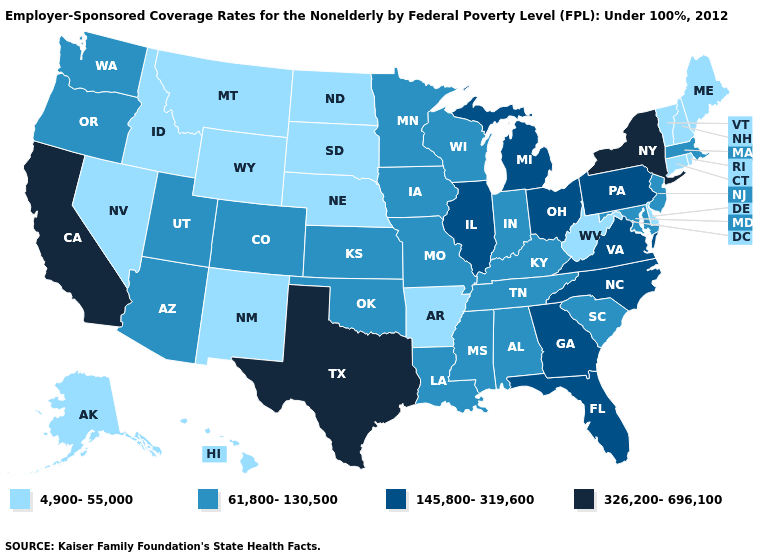What is the value of North Dakota?
Answer briefly. 4,900-55,000. Name the states that have a value in the range 145,800-319,600?
Short answer required. Florida, Georgia, Illinois, Michigan, North Carolina, Ohio, Pennsylvania, Virginia. Name the states that have a value in the range 326,200-696,100?
Write a very short answer. California, New York, Texas. Does the map have missing data?
Short answer required. No. What is the value of Oklahoma?
Quick response, please. 61,800-130,500. Name the states that have a value in the range 326,200-696,100?
Quick response, please. California, New York, Texas. Name the states that have a value in the range 326,200-696,100?
Keep it brief. California, New York, Texas. Name the states that have a value in the range 145,800-319,600?
Concise answer only. Florida, Georgia, Illinois, Michigan, North Carolina, Ohio, Pennsylvania, Virginia. Does the first symbol in the legend represent the smallest category?
Quick response, please. Yes. What is the value of Florida?
Write a very short answer. 145,800-319,600. What is the value of Missouri?
Keep it brief. 61,800-130,500. Name the states that have a value in the range 326,200-696,100?
Quick response, please. California, New York, Texas. Name the states that have a value in the range 145,800-319,600?
Write a very short answer. Florida, Georgia, Illinois, Michigan, North Carolina, Ohio, Pennsylvania, Virginia. Does Minnesota have the highest value in the USA?
Be succinct. No. Name the states that have a value in the range 145,800-319,600?
Short answer required. Florida, Georgia, Illinois, Michigan, North Carolina, Ohio, Pennsylvania, Virginia. 